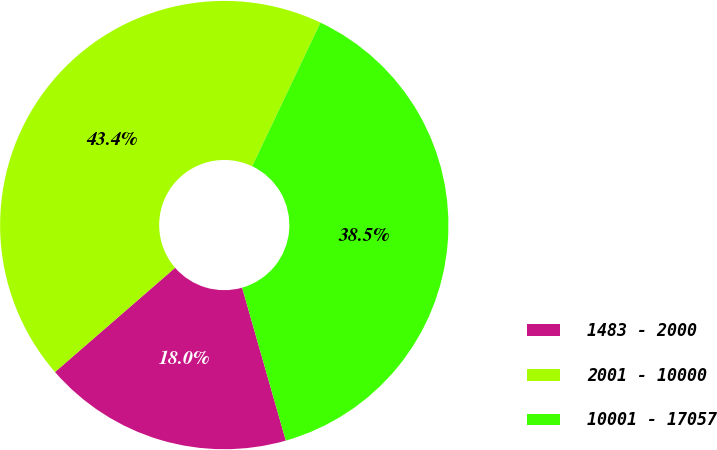Convert chart. <chart><loc_0><loc_0><loc_500><loc_500><pie_chart><fcel>1483 - 2000<fcel>2001 - 10000<fcel>10001 - 17057<nl><fcel>18.05%<fcel>43.44%<fcel>38.51%<nl></chart> 